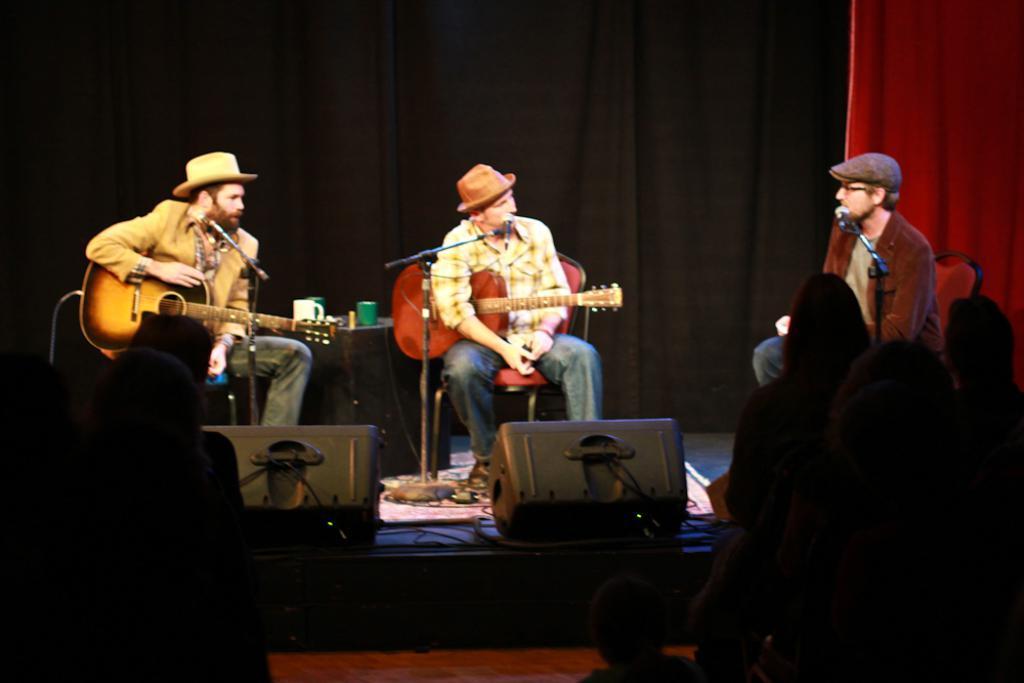In one or two sentences, can you explain what this image depicts? In the image we can see there are three men who are sitting on the chair and they are holding a guitar in their hand and there is a mike in front of them with a stand and the three men are wearing caps. 